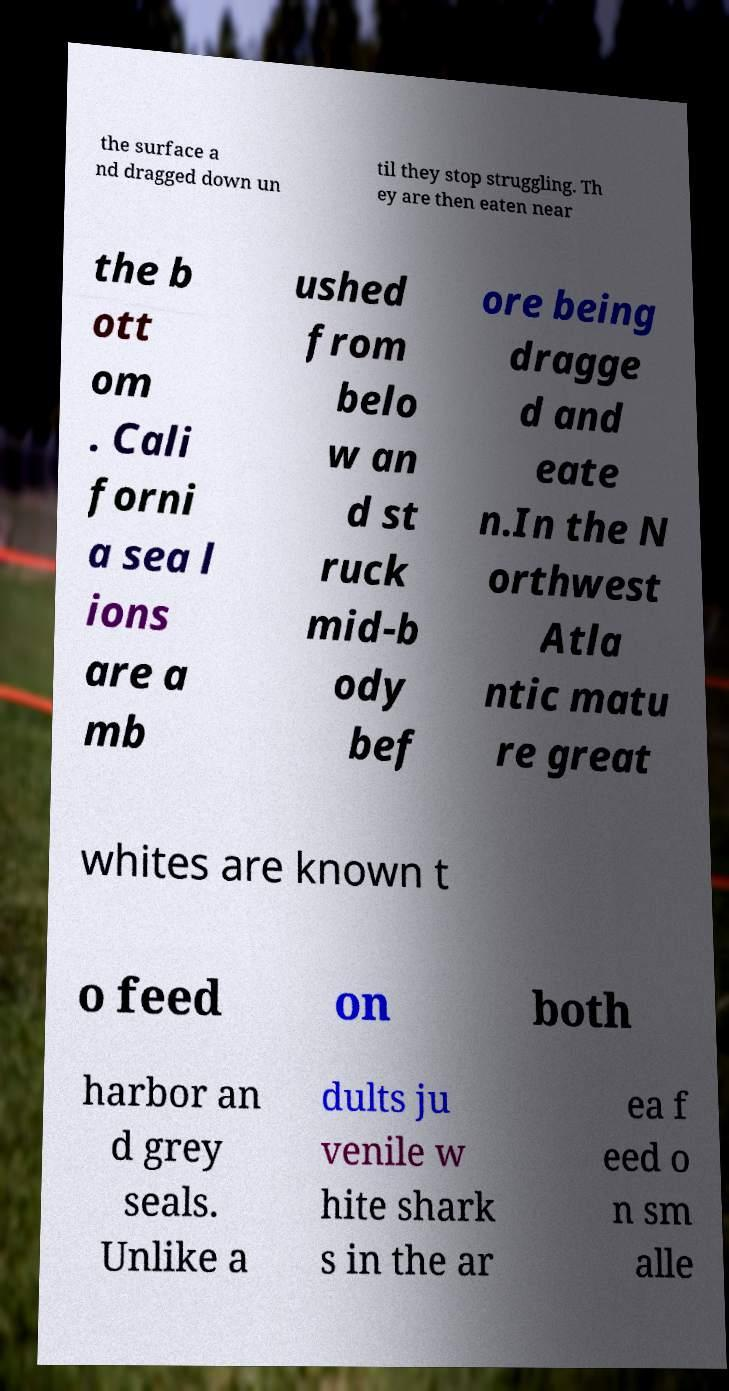For documentation purposes, I need the text within this image transcribed. Could you provide that? the surface a nd dragged down un til they stop struggling. Th ey are then eaten near the b ott om . Cali forni a sea l ions are a mb ushed from belo w an d st ruck mid-b ody bef ore being dragge d and eate n.In the N orthwest Atla ntic matu re great whites are known t o feed on both harbor an d grey seals. Unlike a dults ju venile w hite shark s in the ar ea f eed o n sm alle 